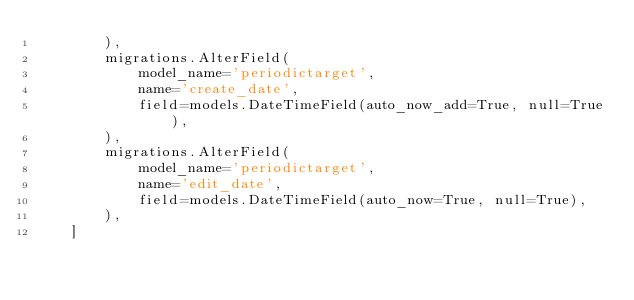Convert code to text. <code><loc_0><loc_0><loc_500><loc_500><_Python_>        ),
        migrations.AlterField(
            model_name='periodictarget',
            name='create_date',
            field=models.DateTimeField(auto_now_add=True, null=True),
        ),
        migrations.AlterField(
            model_name='periodictarget',
            name='edit_date',
            field=models.DateTimeField(auto_now=True, null=True),
        ),
    ]
</code> 